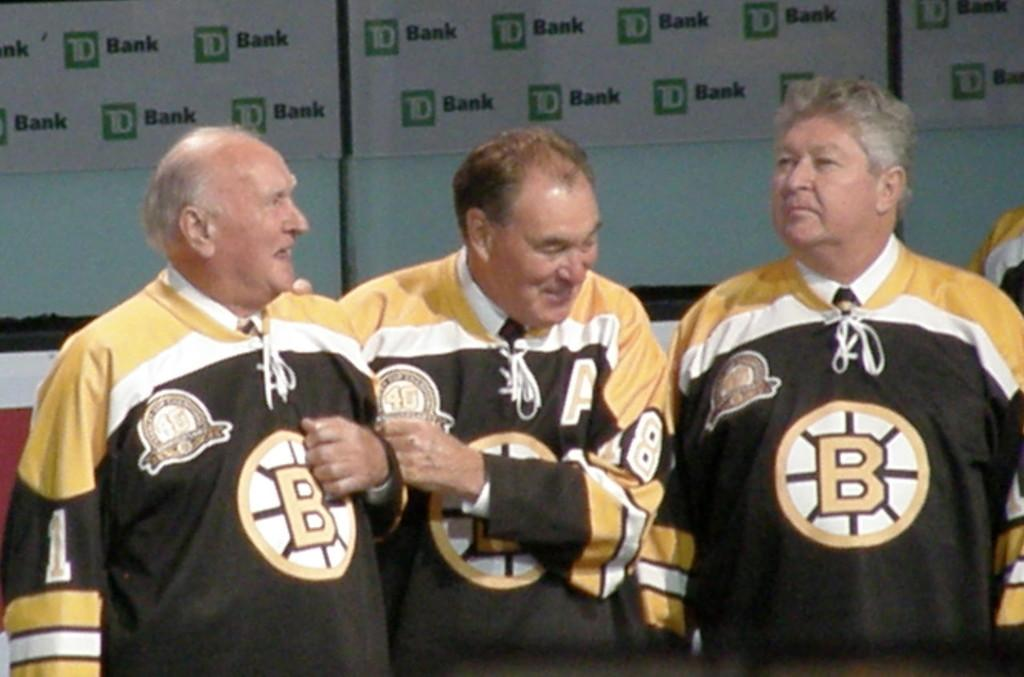<image>
Render a clear and concise summary of the photo. a few people in jerseys and one with the letter B on it 